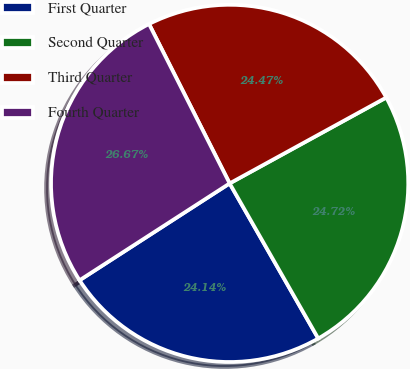Convert chart. <chart><loc_0><loc_0><loc_500><loc_500><pie_chart><fcel>First Quarter<fcel>Second Quarter<fcel>Third Quarter<fcel>Fourth Quarter<nl><fcel>24.14%<fcel>24.72%<fcel>24.47%<fcel>26.67%<nl></chart> 